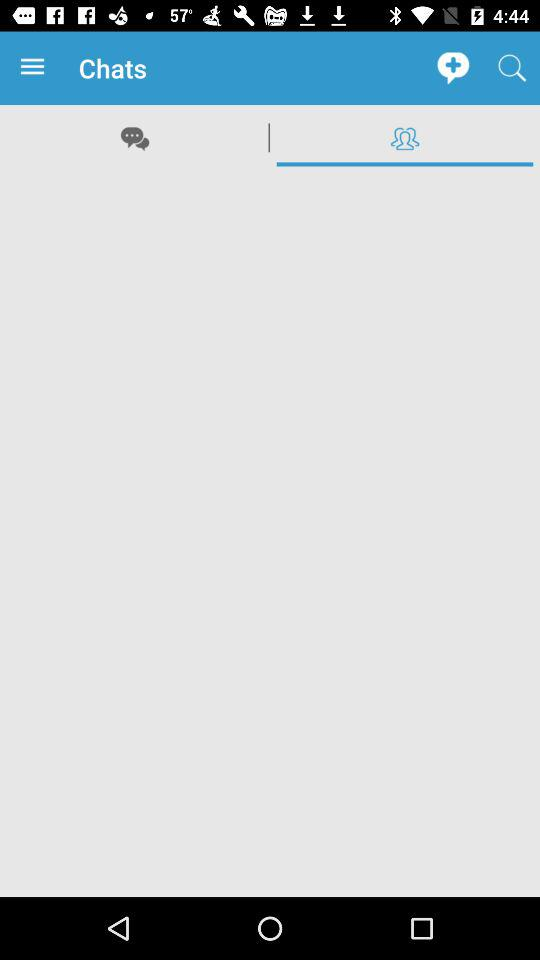Which tab is selected? The selected tab is "Group". 